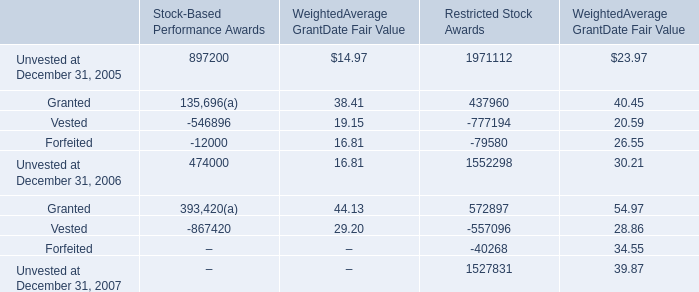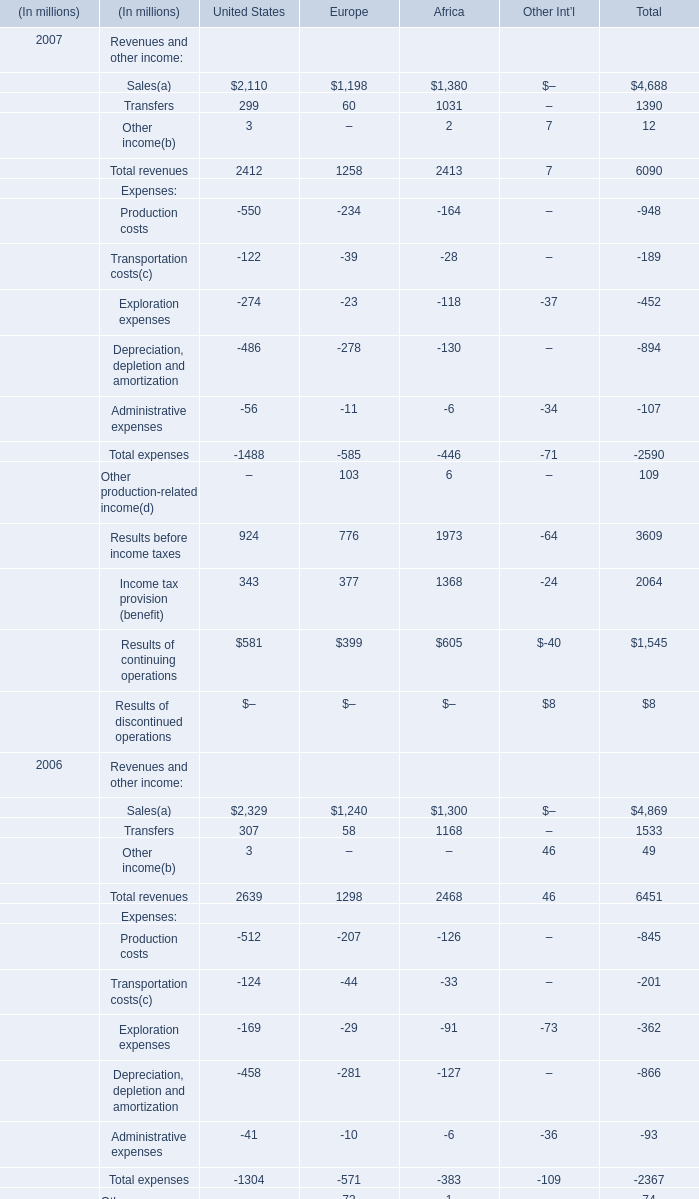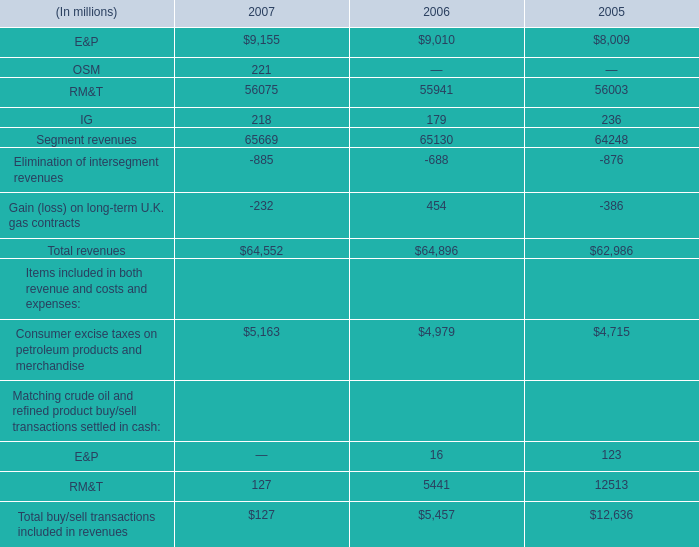What do all Sales sum up, excluding those negative ones in 20007? 
Computations: ((2110 + 1198) + 1380)
Answer: 4688.0. 